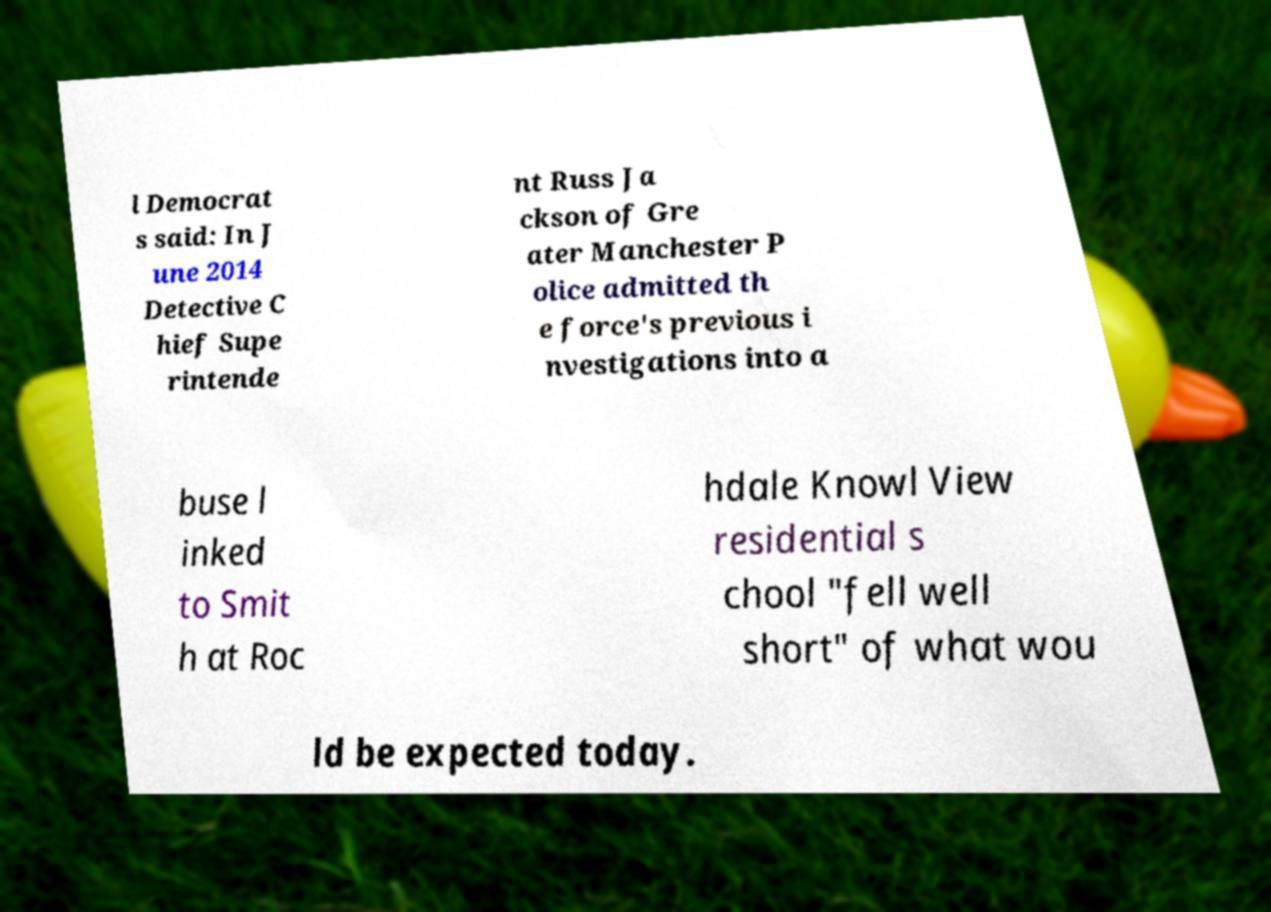Please read and relay the text visible in this image. What does it say? l Democrat s said: In J une 2014 Detective C hief Supe rintende nt Russ Ja ckson of Gre ater Manchester P olice admitted th e force's previous i nvestigations into a buse l inked to Smit h at Roc hdale Knowl View residential s chool "fell well short" of what wou ld be expected today. 